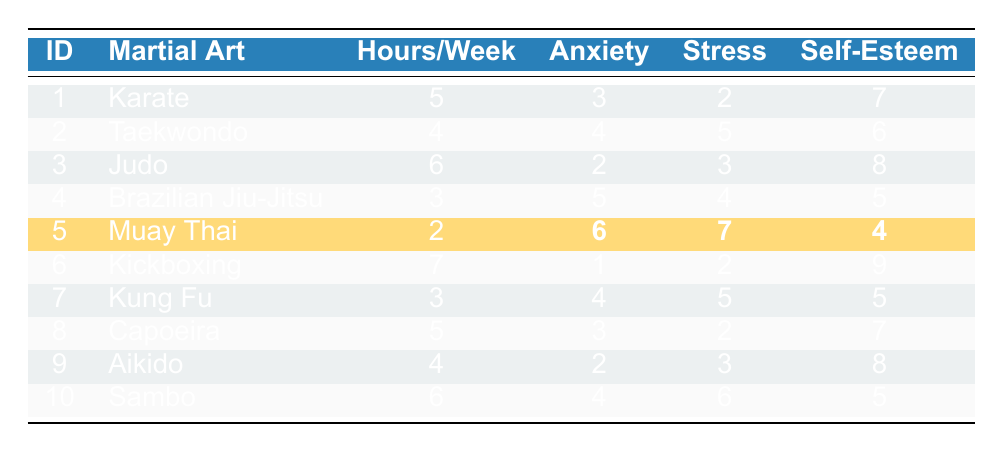What is the martial art practiced by teenager ID 5? Looking at the table, the row for teenager ID 5 shows "Muay Thai" in the Martial Art column.
Answer: Muay Thai What is the reported anxiety level of the teenager training for 3 hours per week? Two teenagers train for 3 hours per week: teenager ID 4 (Brazilian Jiu-Jitsu) has an anxiety level of 5, and teenager ID 7 (Kung Fu) has an anxiety level of 4.
Answer: Teenager ID 4: 5; Teenager ID 7: 4 What is the average self-esteem rating for all teenagers in the table? The self-esteem ratings are 7, 6, 8, 5, 4, 9, 5, 7, 8, and 5. Summing these gives 7 + 6 + 8 + 5 + 4 + 9 + 5 + 7 + 8 + 5 = 64. There are 10 teenagers, so the average self-esteem rating is 64/10 = 6.4.
Answer: 6.4 Which martial art has the highest reported anxiety level? The highest reported anxiety level is 6, which belongs to teenager ID 5 (Muay Thai).
Answer: Muay Thai Does more training hours per week correlate with lower anxiety levels? By evaluating the data, we can see that higher training hours (such as 7 hours for Kickboxing) correspond to lower anxiety levels (1). Similarly, lower training hours (2 for Muay Thai) correspond to higher anxiety levels (6). This indicates an inversely proportional relationship.
Answer: Yes, more training hours correlate with lower anxiety levels Which martial art has the lowest average stress level among the teenagers? The reported stress levels are 2 (Karate), 5 (Taekwondo), 3 (Judo), 4 (Brazilian Jiu-Jitsu), 7 (Muay Thai), 2 (Kickboxing), 5 (Kung Fu), 2 (Capoeira), 3 (Aikido), and 6 (Sambo). The lowest average stress level is 2, associated with Karate, Kickboxing, and Capoeira.
Answer: Karate, Kickboxing, Capoeira Is it true that all teenagers practicing Brazilian Jiu-Jitsu reported higher anxiety than those practicing Judo? Teenager ID 4 practices Brazilian Jiu-Jitsu with a reported anxiety level of 5, while teenager ID 3 practices Judo with a reported anxiety level of 2. Hence, it is true that Brazilian Jiu-Jitsu has higher anxiety.
Answer: Yes What is the combined reported stress level for teenagers practicing Karate and Capoeira? The reported stress for Karate (ID 1) is 2, and for Capoeira (ID 8) is also 2. Adding these yields 2 + 2 = 4.
Answer: 4 